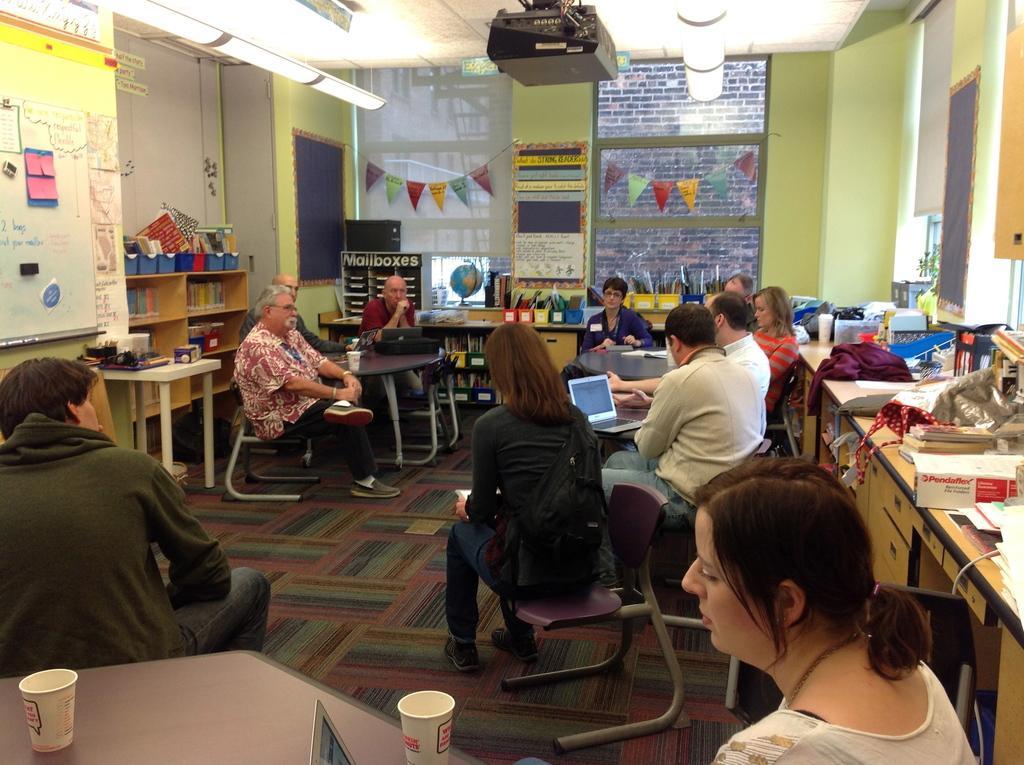Could you give a brief overview of what you see in this image? At the bottom of the image we can see one person and a table. On the table, we can see two glasses and some object. In the center of the image, we can see tables and a few people are sitting on the chairs. On the tables, we can see a laptop, papers, one glass and a few other objects. In the background there is a wall, lights, boards, tables, drawers, clothes, boxes, notes, and a few other objects. 